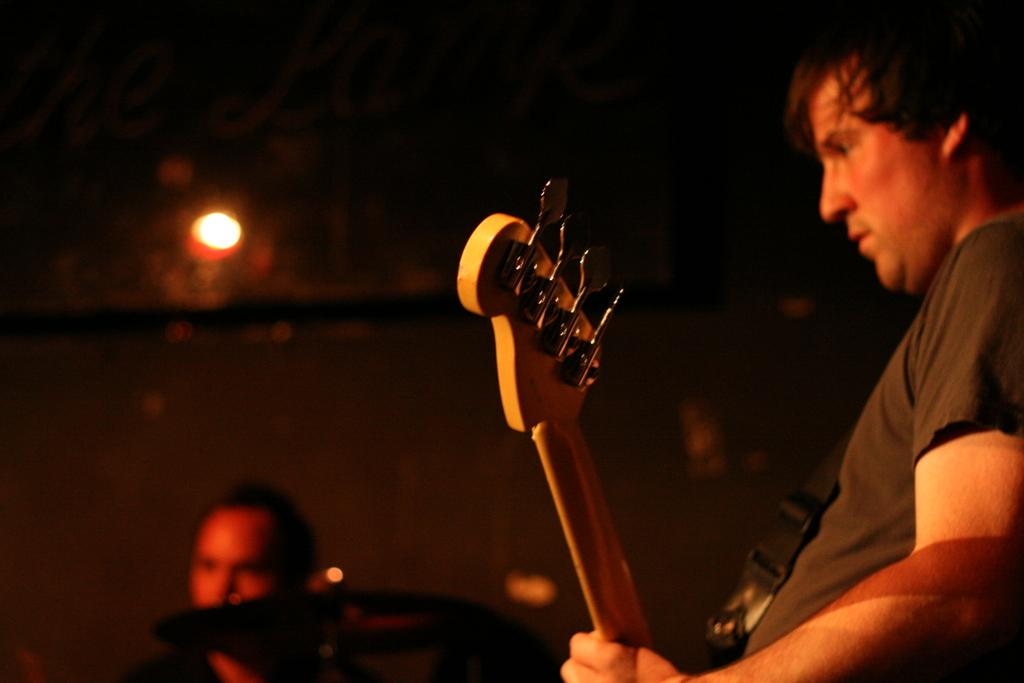How many people are in the image? There are two persons in the image. Can you describe the position of one of the persons? One person is standing on the right side. What is the person on the right side holding? The person on the right side is holding a guitar. What day of the week is depicted in the image? The day of the week is not depicted in the image; it only shows two persons, one of whom is holding a guitar. 